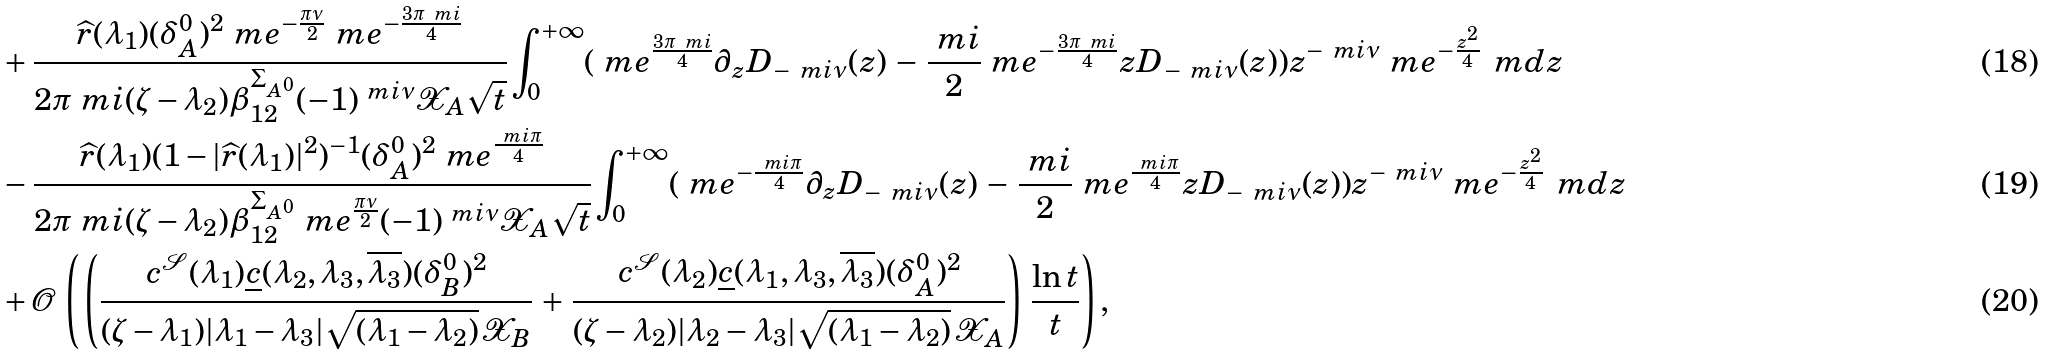Convert formula to latex. <formula><loc_0><loc_0><loc_500><loc_500>& + \frac { \widehat { r } ( \lambda _ { 1 } ) ( \delta _ { A } ^ { 0 } ) ^ { 2 } \ m e ^ { - \frac { \pi \nu } { 2 } } \ m e ^ { - \frac { 3 \pi \ m i } { 4 } } } { 2 \pi \ m i ( \zeta - \lambda _ { 2 } ) \beta ^ { \Sigma _ { A ^ { 0 } } } _ { 1 2 } ( - 1 ) ^ { \ m i \nu } \mathcal { X } _ { A } \sqrt { t } } \int \nolimits _ { 0 } ^ { + \infty } ( \ m e ^ { \frac { 3 \pi \ m i } { 4 } } \partial _ { z } D _ { - \ m i \nu } ( z ) \, - \, \frac { \ m i } { 2 } \ m e ^ { - \frac { 3 \pi \ m i } { 4 } } z D _ { - \ m i \nu } ( z ) ) z ^ { - \ m i \nu } \ m e ^ { - \frac { z ^ { 2 } } { 4 } } \, \ m d z \\ & - \frac { \widehat { r } ( \lambda _ { 1 } ) ( 1 - | \widehat { r } ( \lambda _ { 1 } ) | ^ { 2 } ) ^ { - 1 } ( \delta _ { A } ^ { 0 } ) ^ { 2 } \ m e ^ { \frac { \ m i \pi } { 4 } } } { 2 \pi \ m i ( \zeta - \lambda _ { 2 } ) \beta ^ { \Sigma _ { A ^ { 0 } } } _ { 1 2 } \ m e ^ { \frac { \pi \nu } { 2 } } ( - 1 ) ^ { \ m i \nu } \mathcal { X } _ { A } \sqrt { t } } \int \nolimits _ { 0 } ^ { + \infty } ( \ m e ^ { - \frac { \ m i \pi } { 4 } } \partial _ { z } D _ { - \ m i \nu } ( z ) \, - \, \frac { \ m i } { 2 } \ m e ^ { \frac { \ m i \pi } { 4 } } z D _ { - \ m i \nu } ( z ) ) z ^ { - \ m i \nu } \ m e ^ { - \frac { z ^ { 2 } } { 4 } } \, \ m d z \\ & + \mathcal { O } \, \left ( \, \left ( \frac { c ^ { \mathcal { S } } ( \lambda _ { 1 } ) \underline { c } ( \lambda _ { 2 } , \lambda _ { 3 } , \overline { \lambda _ { 3 } } ) ( \delta _ { B } ^ { 0 } ) ^ { 2 } } { ( \zeta - \lambda _ { 1 } ) | \lambda _ { 1 } - \lambda _ { 3 } | \sqrt { ( \lambda _ { 1 } - \lambda _ { 2 } ) } \, \mathcal { X } _ { B } } \, + \, \frac { c ^ { \mathcal { S } } ( \lambda _ { 2 } ) \underline { c } ( \lambda _ { 1 } , \lambda _ { 3 } , \overline { \lambda _ { 3 } } ) ( \delta _ { A } ^ { 0 } ) ^ { 2 } } { ( \zeta - \lambda _ { 2 } ) | \lambda _ { 2 } - \lambda _ { 3 } | \sqrt { ( \lambda _ { 1 } - \lambda _ { 2 } ) } \, \mathcal { X } _ { A } } \right ) \, \frac { \ln t } { t } \right ) ,</formula> 